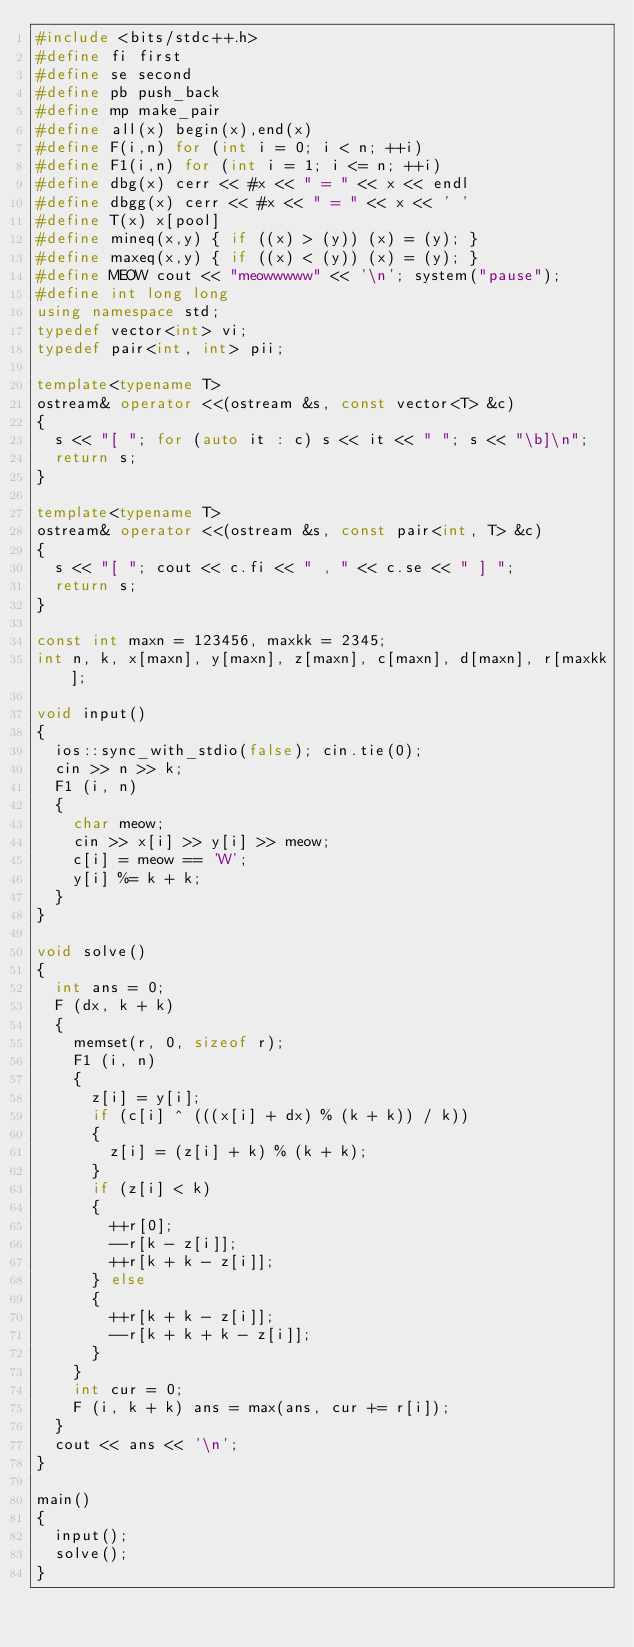<code> <loc_0><loc_0><loc_500><loc_500><_C++_>#include <bits/stdc++.h>
#define fi first
#define se second
#define pb push_back
#define mp make_pair
#define all(x) begin(x),end(x)
#define F(i,n) for (int i = 0; i < n; ++i)
#define F1(i,n) for (int i = 1; i <= n; ++i)
#define dbg(x) cerr << #x << " = " << x << endl
#define dbgg(x) cerr << #x << " = " << x << ' '
#define T(x) x[pool]
#define mineq(x,y) { if ((x) > (y)) (x) = (y); }
#define maxeq(x,y) { if ((x) < (y)) (x) = (y); }
#define MEOW cout << "meowwwww" << '\n'; system("pause");
#define int long long
using namespace std;
typedef vector<int> vi;
typedef pair<int, int> pii;

template<typename T>
ostream& operator <<(ostream &s, const vector<T> &c)
{
	s << "[ "; for (auto it : c) s << it << " "; s << "\b]\n";
	return s;
}

template<typename T>
ostream& operator <<(ostream &s, const pair<int, T> &c)
{
	s << "[ "; cout << c.fi << " , " << c.se << " ] ";
	return s;
}

const int maxn = 123456, maxkk = 2345;
int n, k, x[maxn], y[maxn], z[maxn], c[maxn], d[maxn], r[maxkk];

void input()
{
	ios::sync_with_stdio(false); cin.tie(0);
	cin >> n >> k;
	F1 (i, n)
	{
		char meow;
		cin >> x[i] >> y[i] >> meow;
		c[i] = meow == 'W';
		y[i] %= k + k; 
	} 
}

void solve()
{
	int ans = 0;
	F (dx, k + k)
	{
		memset(r, 0, sizeof r);
		F1 (i, n)
		{
			z[i] = y[i];
			if (c[i] ^ (((x[i] + dx) % (k + k)) / k))
			{
				z[i] = (z[i] + k) % (k + k);
			}
			if (z[i] < k)
			{
				++r[0];
				--r[k - z[i]];
				++r[k + k - z[i]];
			} else
			{
				++r[k + k - z[i]];
				--r[k + k + k - z[i]];
			}
		}
		int cur = 0;
		F (i, k + k) ans = max(ans, cur += r[i]);
	}
	cout << ans << '\n';
}

main()
{
	input();
	solve();
}
</code> 